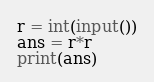Convert code to text. <code><loc_0><loc_0><loc_500><loc_500><_Python_>r = int(input())
ans = r*r
print(ans)</code> 